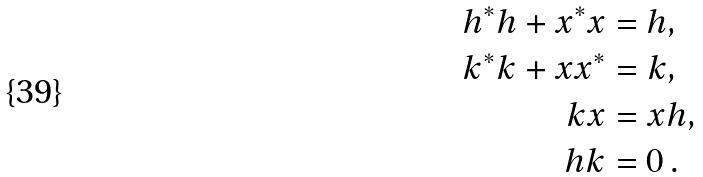<formula> <loc_0><loc_0><loc_500><loc_500>h ^ { * } h + x ^ { * } x & = h , \\ k ^ { * } k + x x ^ { * } & = k , \\ k x & = x h , \\ h k & = 0 \, .</formula> 